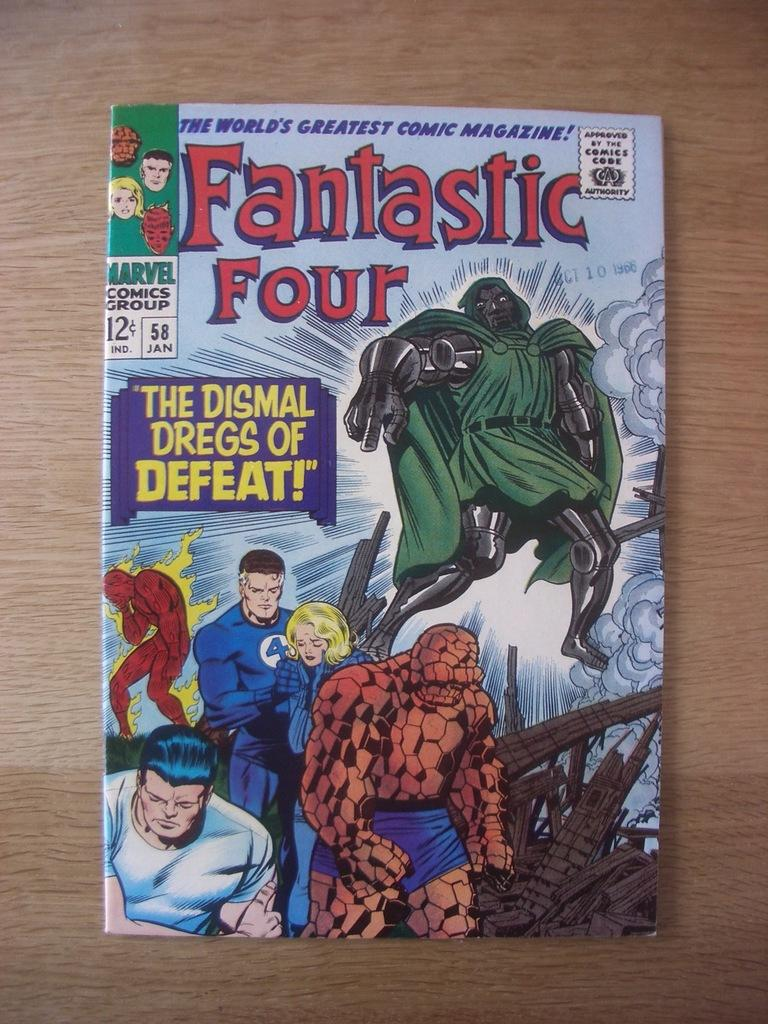<image>
Share a concise interpretation of the image provided. Magazine cover for Fantastic Four showing the heroes looking scared. 